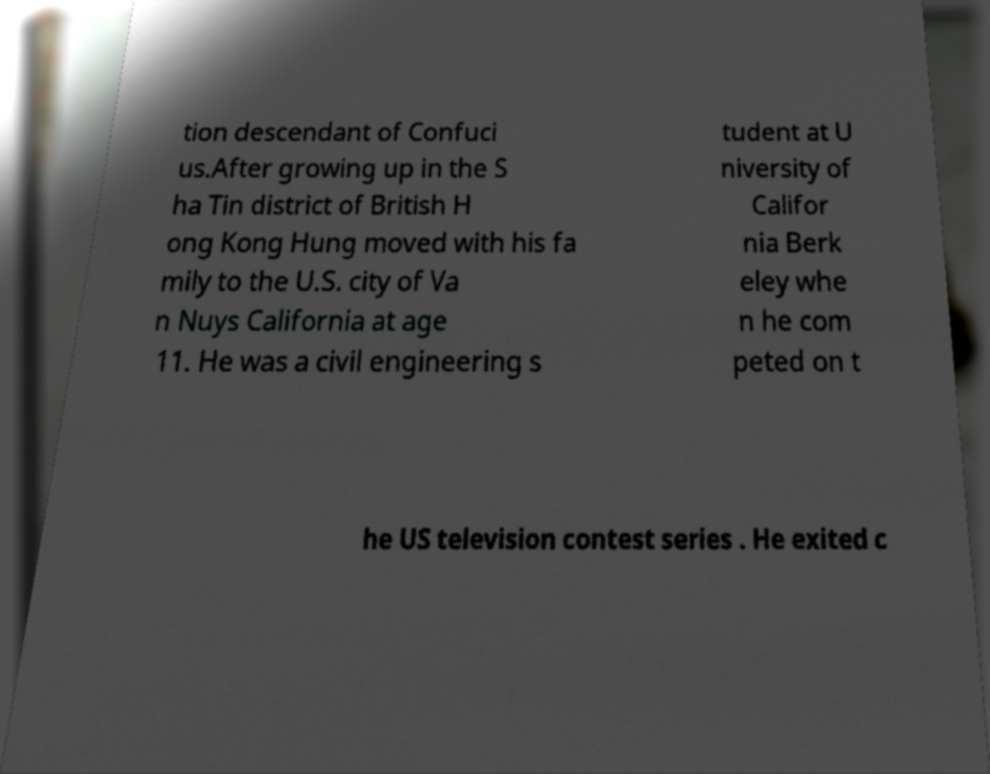For documentation purposes, I need the text within this image transcribed. Could you provide that? tion descendant of Confuci us.After growing up in the S ha Tin district of British H ong Kong Hung moved with his fa mily to the U.S. city of Va n Nuys California at age 11. He was a civil engineering s tudent at U niversity of Califor nia Berk eley whe n he com peted on t he US television contest series . He exited c 